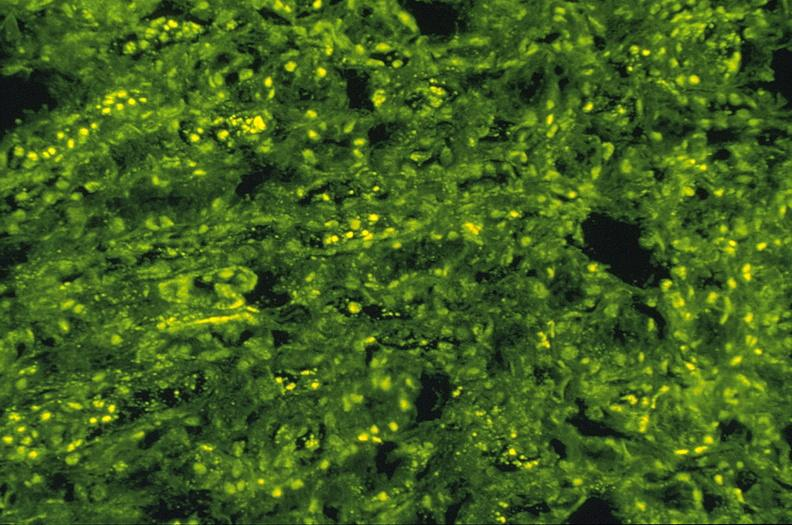where is this?
Answer the question using a single word or phrase. Urinary 